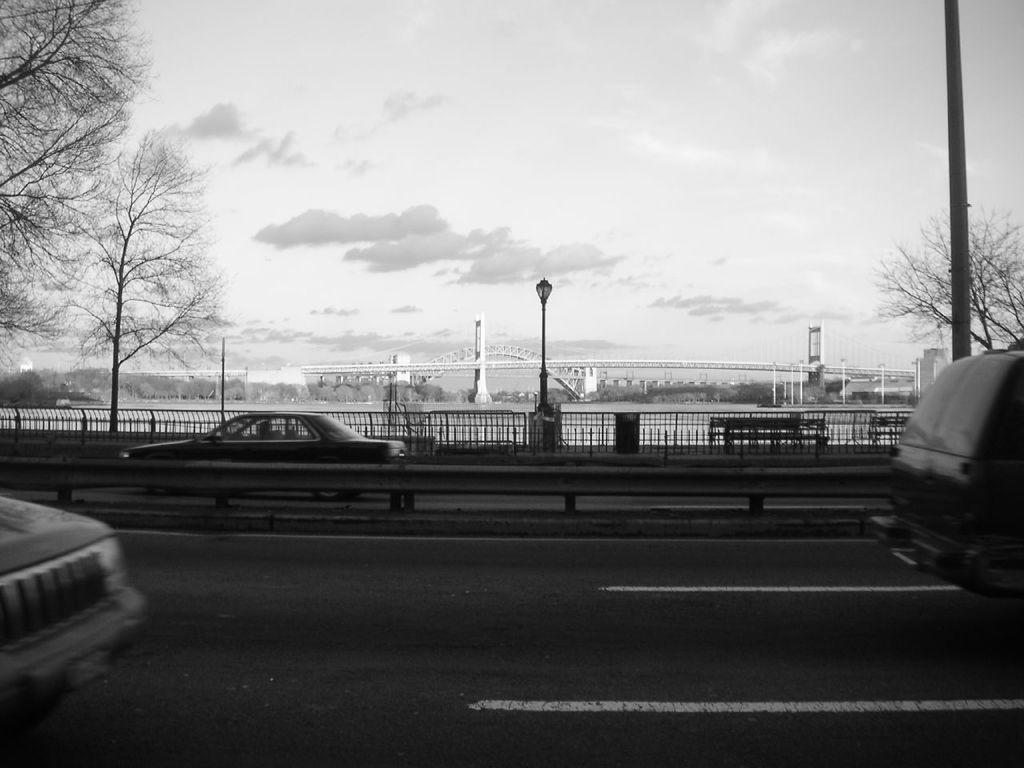Could you give a brief overview of what you see in this image? In the picture I can see vehicles on the road. In the background I can see trees, fence, street lights, bridge, buildings and the sky. This picture is black and white in color. 